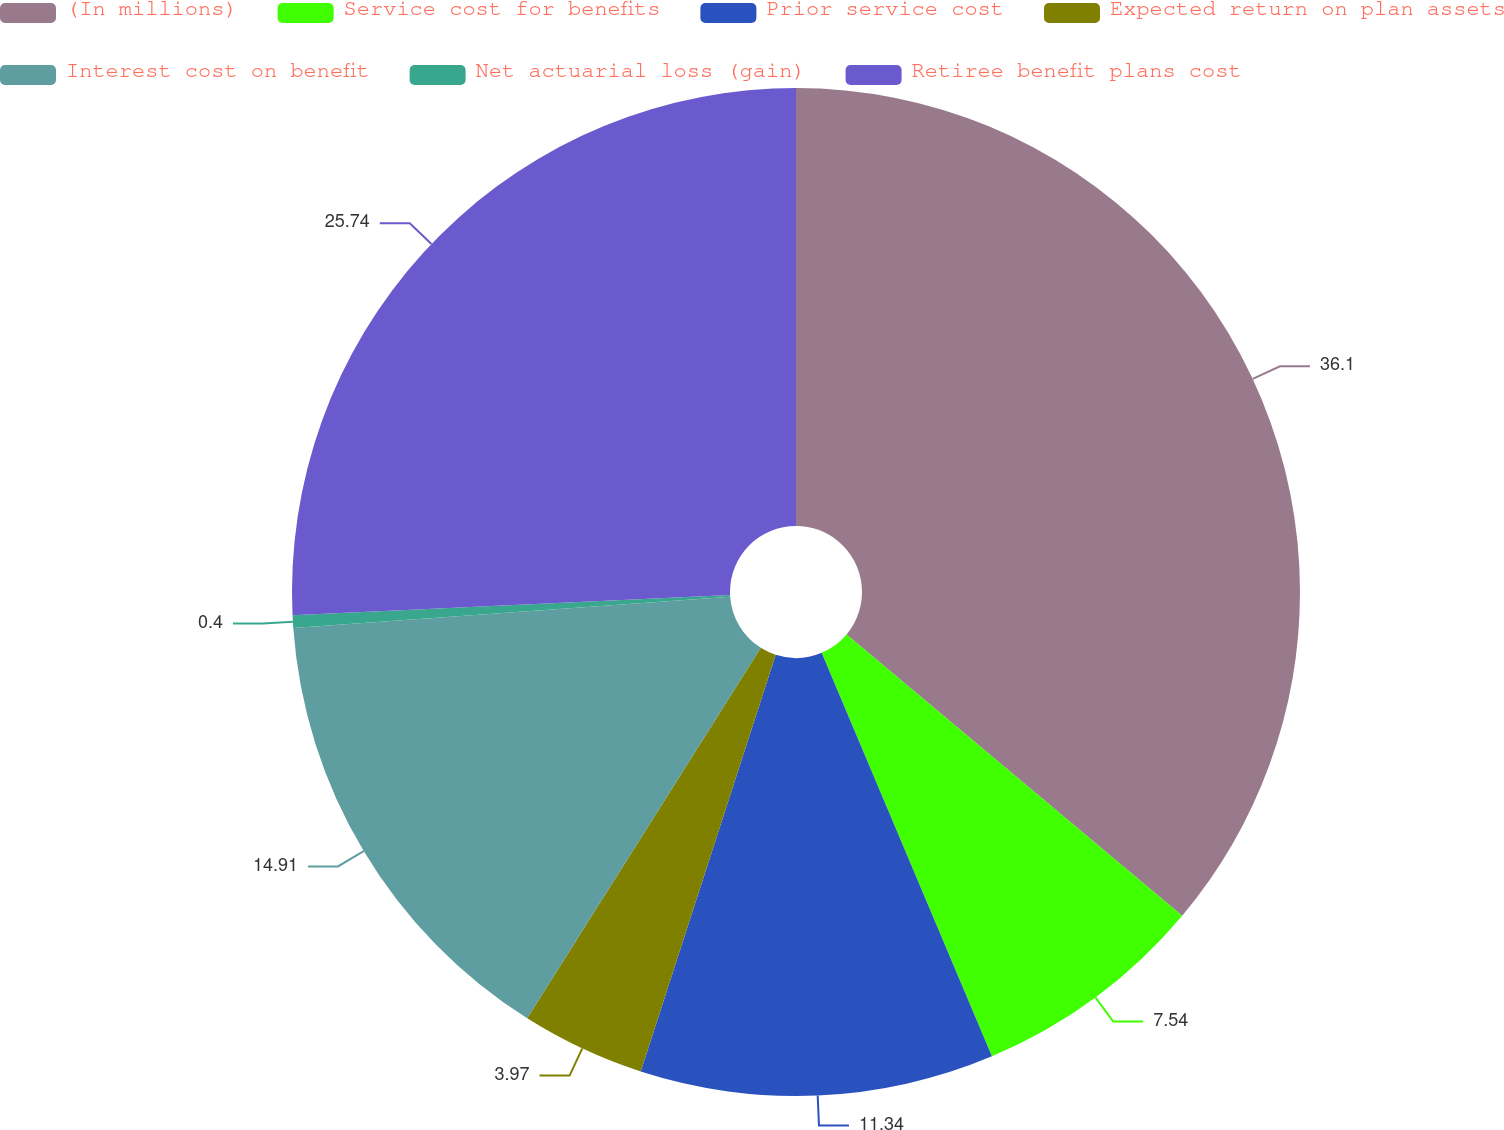Convert chart to OTSL. <chart><loc_0><loc_0><loc_500><loc_500><pie_chart><fcel>(In millions)<fcel>Service cost for benefits<fcel>Prior service cost<fcel>Expected return on plan assets<fcel>Interest cost on benefit<fcel>Net actuarial loss (gain)<fcel>Retiree benefit plans cost<nl><fcel>36.11%<fcel>7.54%<fcel>11.34%<fcel>3.97%<fcel>14.91%<fcel>0.4%<fcel>25.74%<nl></chart> 